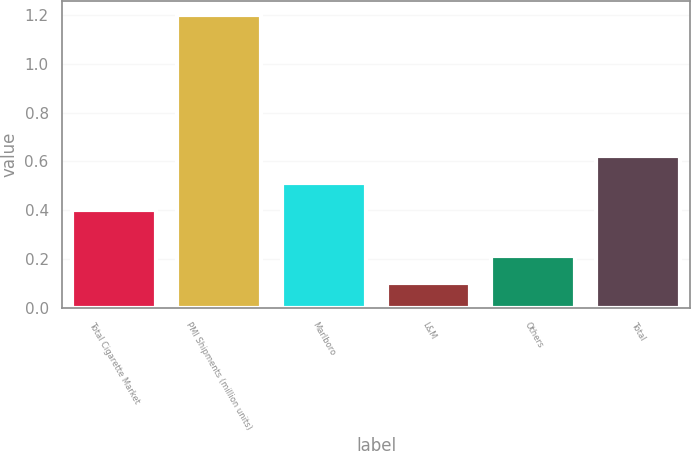Convert chart. <chart><loc_0><loc_0><loc_500><loc_500><bar_chart><fcel>Total Cigarette Market<fcel>PMI Shipments (million units)<fcel>Marlboro<fcel>L&M<fcel>Others<fcel>Total<nl><fcel>0.4<fcel>1.2<fcel>0.51<fcel>0.1<fcel>0.21<fcel>0.62<nl></chart> 